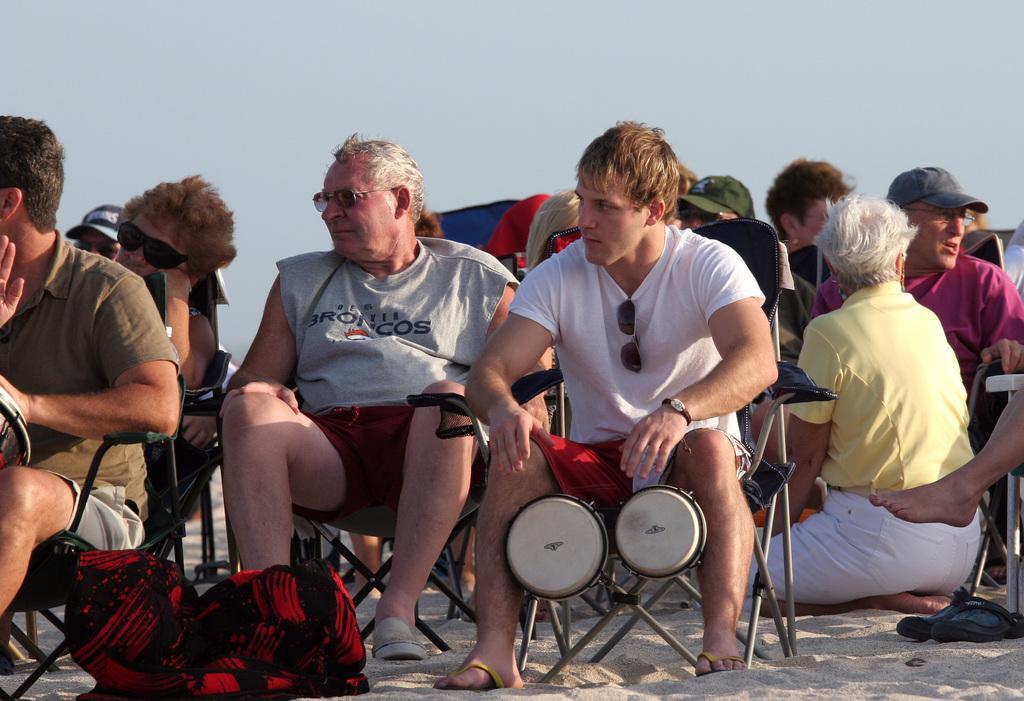Could you give a brief overview of what you see in this image? Few people are sitting on the chairs at the bottom it's a sand and a sky in the top. 